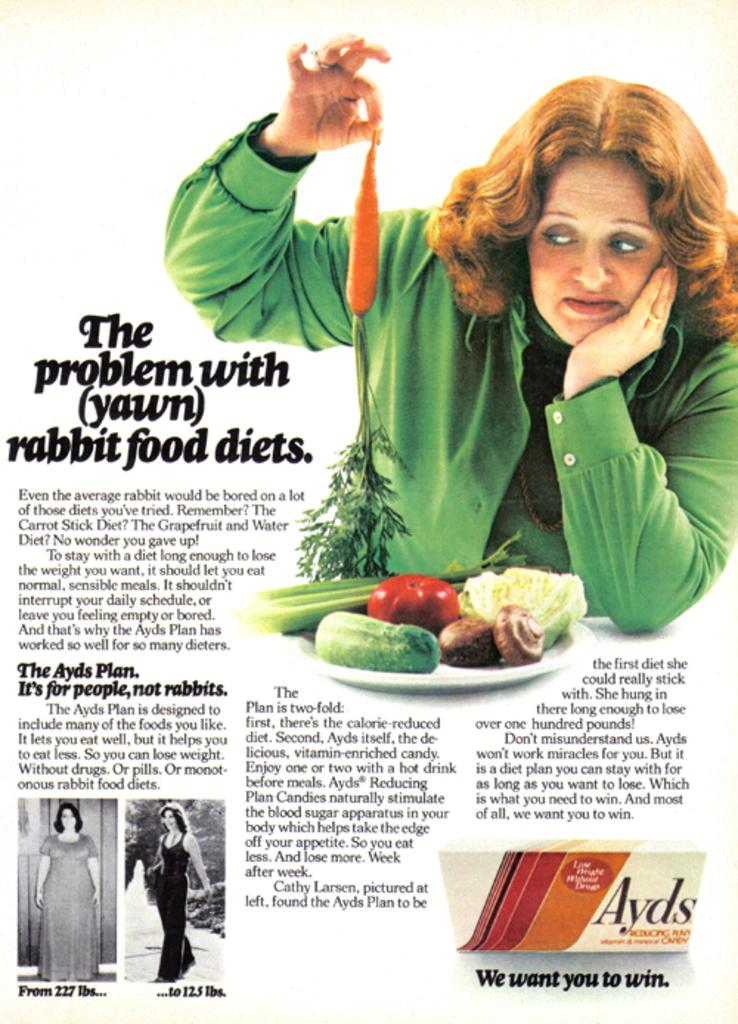<image>
Create a compact narrative representing the image presented. a page that says 'the problem with (yawn) rabbit food diets.' 